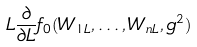Convert formula to latex. <formula><loc_0><loc_0><loc_500><loc_500>L \frac { \partial } { \partial L } f _ { 0 } ( W _ { 1 L } , \dots , W _ { n L } , g ^ { 2 } )</formula> 